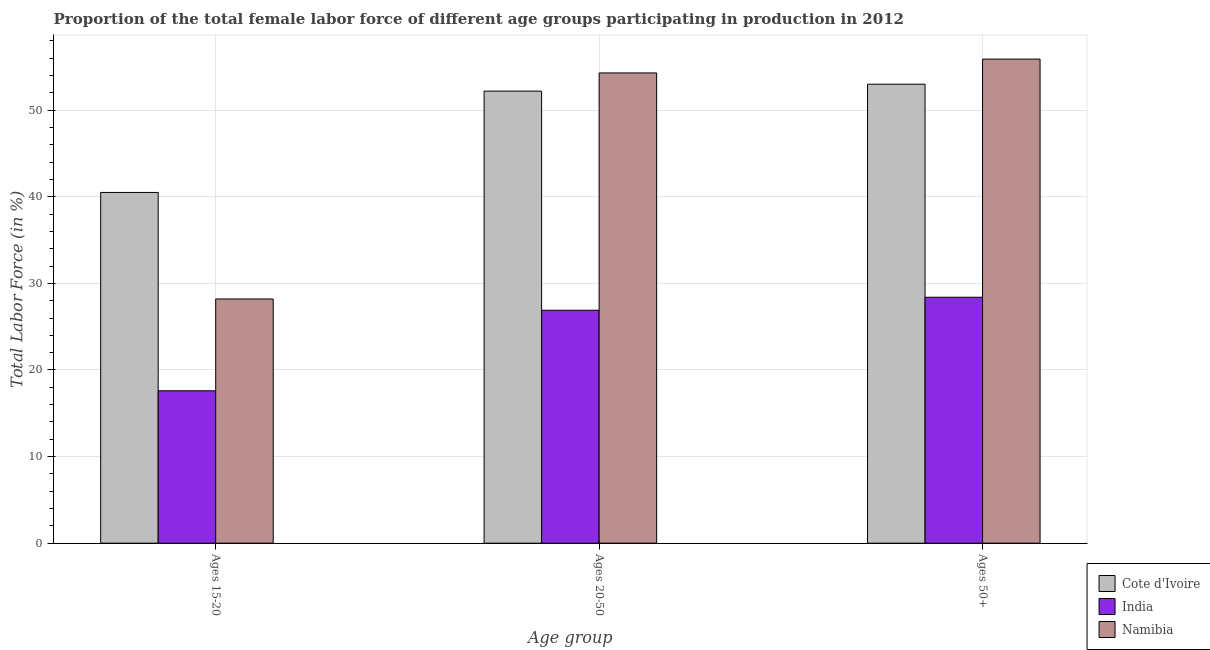How many different coloured bars are there?
Your answer should be compact. 3. How many groups of bars are there?
Keep it short and to the point. 3. What is the label of the 3rd group of bars from the left?
Make the answer very short. Ages 50+. Across all countries, what is the maximum percentage of female labor force above age 50?
Make the answer very short. 55.9. Across all countries, what is the minimum percentage of female labor force within the age group 15-20?
Your answer should be very brief. 17.6. In which country was the percentage of female labor force within the age group 20-50 maximum?
Keep it short and to the point. Namibia. What is the total percentage of female labor force within the age group 20-50 in the graph?
Provide a short and direct response. 133.4. What is the difference between the percentage of female labor force within the age group 15-20 in Namibia and that in Cote d'Ivoire?
Your response must be concise. -12.3. What is the difference between the percentage of female labor force within the age group 20-50 in Cote d'Ivoire and the percentage of female labor force above age 50 in Namibia?
Provide a short and direct response. -3.7. What is the average percentage of female labor force within the age group 20-50 per country?
Ensure brevity in your answer.  44.47. What is the difference between the percentage of female labor force within the age group 20-50 and percentage of female labor force within the age group 15-20 in India?
Your response must be concise. 9.3. What is the ratio of the percentage of female labor force within the age group 15-20 in India to that in Cote d'Ivoire?
Make the answer very short. 0.43. Is the percentage of female labor force within the age group 15-20 in Cote d'Ivoire less than that in India?
Your answer should be very brief. No. Is the difference between the percentage of female labor force within the age group 15-20 in Namibia and India greater than the difference between the percentage of female labor force above age 50 in Namibia and India?
Provide a succinct answer. No. What is the difference between the highest and the second highest percentage of female labor force within the age group 20-50?
Provide a short and direct response. 2.1. What is the difference between the highest and the lowest percentage of female labor force above age 50?
Make the answer very short. 27.5. In how many countries, is the percentage of female labor force within the age group 20-50 greater than the average percentage of female labor force within the age group 20-50 taken over all countries?
Offer a terse response. 2. Is the sum of the percentage of female labor force within the age group 15-20 in Cote d'Ivoire and India greater than the maximum percentage of female labor force within the age group 20-50 across all countries?
Your answer should be very brief. Yes. What does the 3rd bar from the left in Ages 15-20 represents?
Provide a succinct answer. Namibia. What does the 1st bar from the right in Ages 50+ represents?
Keep it short and to the point. Namibia. Is it the case that in every country, the sum of the percentage of female labor force within the age group 15-20 and percentage of female labor force within the age group 20-50 is greater than the percentage of female labor force above age 50?
Make the answer very short. Yes. Are all the bars in the graph horizontal?
Provide a short and direct response. No. How many countries are there in the graph?
Your response must be concise. 3. What is the difference between two consecutive major ticks on the Y-axis?
Provide a succinct answer. 10. Are the values on the major ticks of Y-axis written in scientific E-notation?
Provide a short and direct response. No. Does the graph contain grids?
Ensure brevity in your answer.  Yes. How are the legend labels stacked?
Offer a very short reply. Vertical. What is the title of the graph?
Give a very brief answer. Proportion of the total female labor force of different age groups participating in production in 2012. What is the label or title of the X-axis?
Provide a short and direct response. Age group. What is the Total Labor Force (in %) of Cote d'Ivoire in Ages 15-20?
Offer a very short reply. 40.5. What is the Total Labor Force (in %) of India in Ages 15-20?
Your answer should be compact. 17.6. What is the Total Labor Force (in %) in Namibia in Ages 15-20?
Offer a terse response. 28.2. What is the Total Labor Force (in %) of Cote d'Ivoire in Ages 20-50?
Your response must be concise. 52.2. What is the Total Labor Force (in %) of India in Ages 20-50?
Your answer should be very brief. 26.9. What is the Total Labor Force (in %) of Namibia in Ages 20-50?
Your answer should be compact. 54.3. What is the Total Labor Force (in %) in India in Ages 50+?
Offer a very short reply. 28.4. What is the Total Labor Force (in %) in Namibia in Ages 50+?
Provide a short and direct response. 55.9. Across all Age group, what is the maximum Total Labor Force (in %) of Cote d'Ivoire?
Your answer should be very brief. 53. Across all Age group, what is the maximum Total Labor Force (in %) of India?
Provide a succinct answer. 28.4. Across all Age group, what is the maximum Total Labor Force (in %) of Namibia?
Keep it short and to the point. 55.9. Across all Age group, what is the minimum Total Labor Force (in %) in Cote d'Ivoire?
Offer a very short reply. 40.5. Across all Age group, what is the minimum Total Labor Force (in %) in India?
Offer a very short reply. 17.6. Across all Age group, what is the minimum Total Labor Force (in %) of Namibia?
Provide a succinct answer. 28.2. What is the total Total Labor Force (in %) of Cote d'Ivoire in the graph?
Offer a terse response. 145.7. What is the total Total Labor Force (in %) of India in the graph?
Your answer should be very brief. 72.9. What is the total Total Labor Force (in %) of Namibia in the graph?
Your response must be concise. 138.4. What is the difference between the Total Labor Force (in %) in Cote d'Ivoire in Ages 15-20 and that in Ages 20-50?
Ensure brevity in your answer.  -11.7. What is the difference between the Total Labor Force (in %) of Namibia in Ages 15-20 and that in Ages 20-50?
Your response must be concise. -26.1. What is the difference between the Total Labor Force (in %) in Cote d'Ivoire in Ages 15-20 and that in Ages 50+?
Make the answer very short. -12.5. What is the difference between the Total Labor Force (in %) of Namibia in Ages 15-20 and that in Ages 50+?
Your answer should be very brief. -27.7. What is the difference between the Total Labor Force (in %) in India in Ages 20-50 and that in Ages 50+?
Keep it short and to the point. -1.5. What is the difference between the Total Labor Force (in %) in Namibia in Ages 20-50 and that in Ages 50+?
Provide a succinct answer. -1.6. What is the difference between the Total Labor Force (in %) of India in Ages 15-20 and the Total Labor Force (in %) of Namibia in Ages 20-50?
Your answer should be compact. -36.7. What is the difference between the Total Labor Force (in %) in Cote d'Ivoire in Ages 15-20 and the Total Labor Force (in %) in India in Ages 50+?
Ensure brevity in your answer.  12.1. What is the difference between the Total Labor Force (in %) in Cote d'Ivoire in Ages 15-20 and the Total Labor Force (in %) in Namibia in Ages 50+?
Give a very brief answer. -15.4. What is the difference between the Total Labor Force (in %) of India in Ages 15-20 and the Total Labor Force (in %) of Namibia in Ages 50+?
Your response must be concise. -38.3. What is the difference between the Total Labor Force (in %) in Cote d'Ivoire in Ages 20-50 and the Total Labor Force (in %) in India in Ages 50+?
Provide a short and direct response. 23.8. What is the difference between the Total Labor Force (in %) of Cote d'Ivoire in Ages 20-50 and the Total Labor Force (in %) of Namibia in Ages 50+?
Keep it short and to the point. -3.7. What is the difference between the Total Labor Force (in %) in India in Ages 20-50 and the Total Labor Force (in %) in Namibia in Ages 50+?
Ensure brevity in your answer.  -29. What is the average Total Labor Force (in %) in Cote d'Ivoire per Age group?
Make the answer very short. 48.57. What is the average Total Labor Force (in %) in India per Age group?
Give a very brief answer. 24.3. What is the average Total Labor Force (in %) in Namibia per Age group?
Your answer should be very brief. 46.13. What is the difference between the Total Labor Force (in %) of Cote d'Ivoire and Total Labor Force (in %) of India in Ages 15-20?
Keep it short and to the point. 22.9. What is the difference between the Total Labor Force (in %) in Cote d'Ivoire and Total Labor Force (in %) in Namibia in Ages 15-20?
Keep it short and to the point. 12.3. What is the difference between the Total Labor Force (in %) in Cote d'Ivoire and Total Labor Force (in %) in India in Ages 20-50?
Offer a terse response. 25.3. What is the difference between the Total Labor Force (in %) in India and Total Labor Force (in %) in Namibia in Ages 20-50?
Give a very brief answer. -27.4. What is the difference between the Total Labor Force (in %) of Cote d'Ivoire and Total Labor Force (in %) of India in Ages 50+?
Your answer should be very brief. 24.6. What is the difference between the Total Labor Force (in %) in India and Total Labor Force (in %) in Namibia in Ages 50+?
Your answer should be compact. -27.5. What is the ratio of the Total Labor Force (in %) of Cote d'Ivoire in Ages 15-20 to that in Ages 20-50?
Offer a very short reply. 0.78. What is the ratio of the Total Labor Force (in %) in India in Ages 15-20 to that in Ages 20-50?
Give a very brief answer. 0.65. What is the ratio of the Total Labor Force (in %) of Namibia in Ages 15-20 to that in Ages 20-50?
Make the answer very short. 0.52. What is the ratio of the Total Labor Force (in %) in Cote d'Ivoire in Ages 15-20 to that in Ages 50+?
Keep it short and to the point. 0.76. What is the ratio of the Total Labor Force (in %) in India in Ages 15-20 to that in Ages 50+?
Give a very brief answer. 0.62. What is the ratio of the Total Labor Force (in %) in Namibia in Ages 15-20 to that in Ages 50+?
Provide a succinct answer. 0.5. What is the ratio of the Total Labor Force (in %) of Cote d'Ivoire in Ages 20-50 to that in Ages 50+?
Offer a terse response. 0.98. What is the ratio of the Total Labor Force (in %) in India in Ages 20-50 to that in Ages 50+?
Your answer should be compact. 0.95. What is the ratio of the Total Labor Force (in %) in Namibia in Ages 20-50 to that in Ages 50+?
Your response must be concise. 0.97. What is the difference between the highest and the second highest Total Labor Force (in %) of Cote d'Ivoire?
Your answer should be very brief. 0.8. What is the difference between the highest and the second highest Total Labor Force (in %) in Namibia?
Provide a succinct answer. 1.6. What is the difference between the highest and the lowest Total Labor Force (in %) of Cote d'Ivoire?
Offer a terse response. 12.5. What is the difference between the highest and the lowest Total Labor Force (in %) of India?
Provide a short and direct response. 10.8. What is the difference between the highest and the lowest Total Labor Force (in %) in Namibia?
Your answer should be very brief. 27.7. 